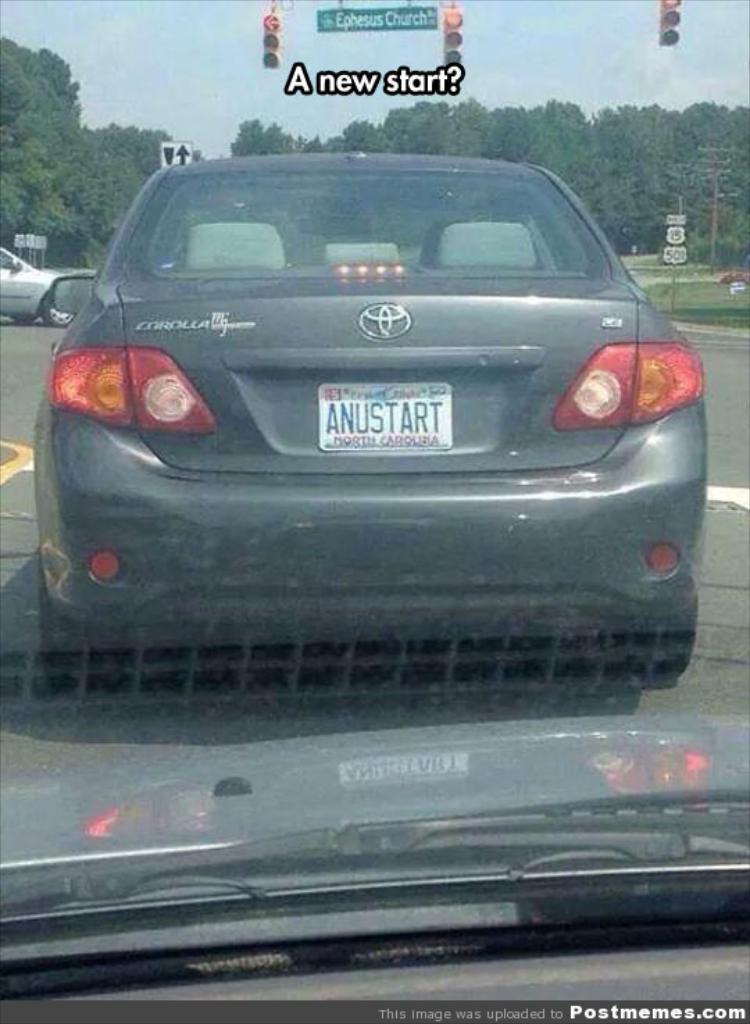What is the license plate of the car?
Your answer should be very brief. Anustart. Is this car a toyota corolla?
Make the answer very short. Yes. 